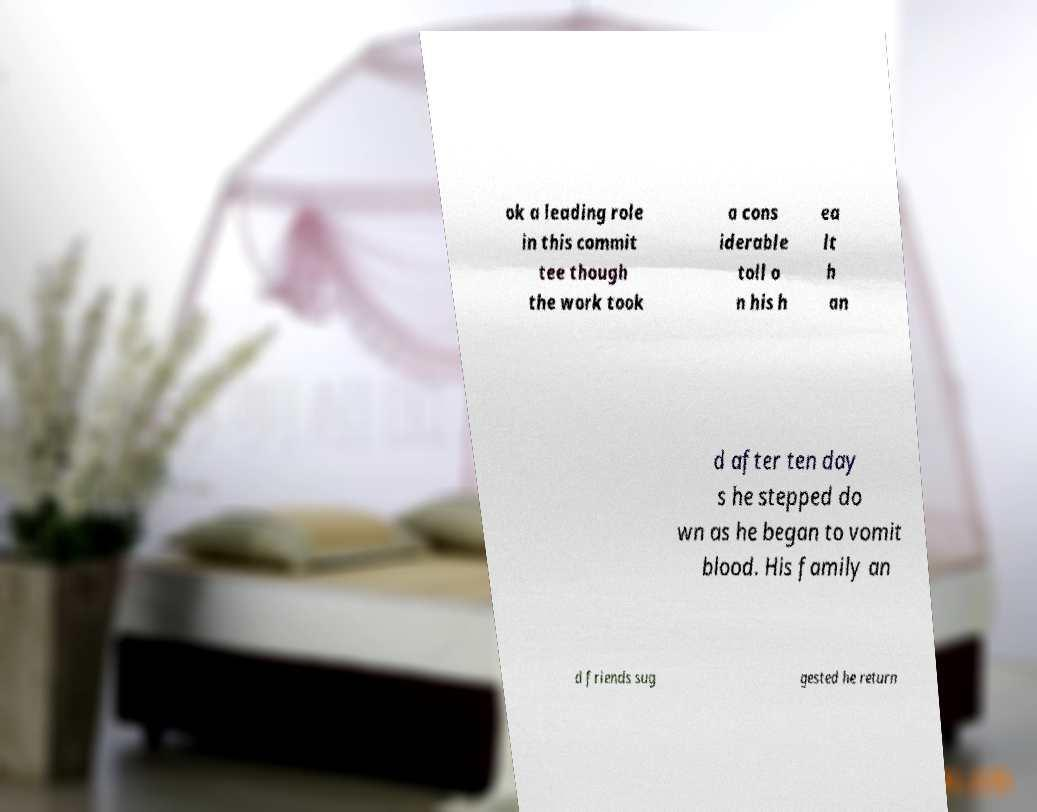Can you read and provide the text displayed in the image?This photo seems to have some interesting text. Can you extract and type it out for me? ok a leading role in this commit tee though the work took a cons iderable toll o n his h ea lt h an d after ten day s he stepped do wn as he began to vomit blood. His family an d friends sug gested he return 